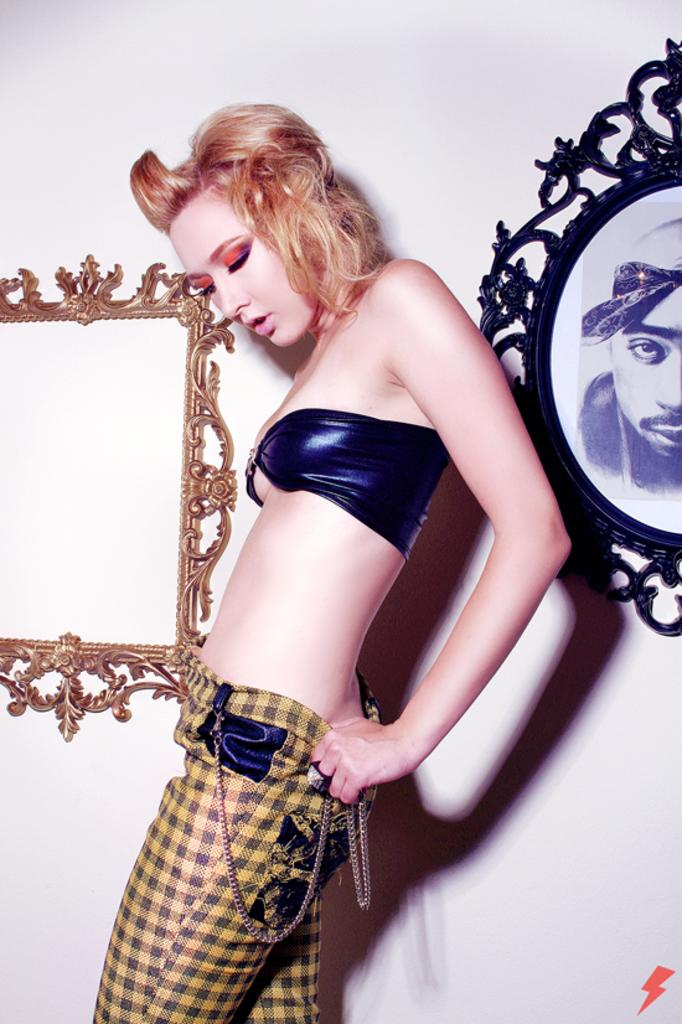What is the main subject in the center of the picture? There is a woman standing in the center of the picture. What can be seen on the right side of the picture? There is a frame on the right side of the picture. What can be seen on the left side of the picture? There is a frame on the left side of the picture. What color is the wall in the background? The wall is painted white. What type of fiction is the woman reading in the image? There is no book or any indication of reading in the image, so it cannot be determined if the woman is reading fiction or any other type of literature. 